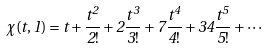Convert formula to latex. <formula><loc_0><loc_0><loc_500><loc_500>\chi ( t , 1 ) = t + \frac { t ^ { 2 } } { 2 ! } + 2 \frac { t ^ { 3 } } { 3 ! } + 7 \frac { t ^ { 4 } } { 4 ! } + 3 4 \frac { t ^ { 5 } } { 5 ! } + \cdots</formula> 